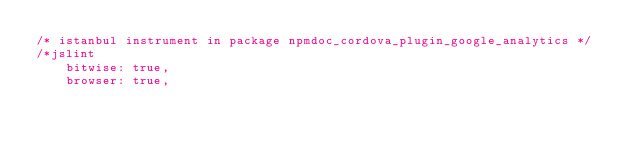<code> <loc_0><loc_0><loc_500><loc_500><_JavaScript_>/* istanbul instrument in package npmdoc_cordova_plugin_google_analytics */
/*jslint
    bitwise: true,
    browser: true,</code> 